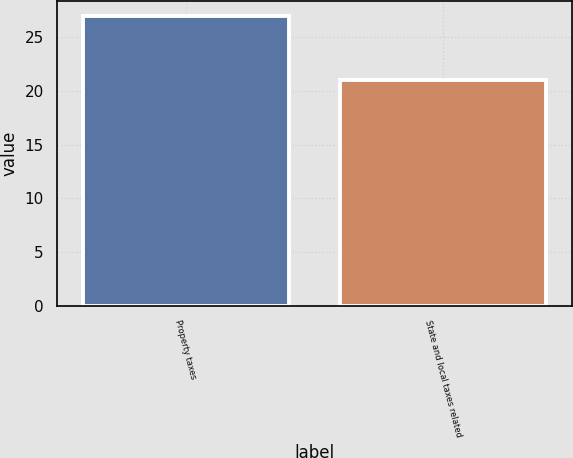<chart> <loc_0><loc_0><loc_500><loc_500><bar_chart><fcel>Property taxes<fcel>State and local taxes related<nl><fcel>27<fcel>21<nl></chart> 